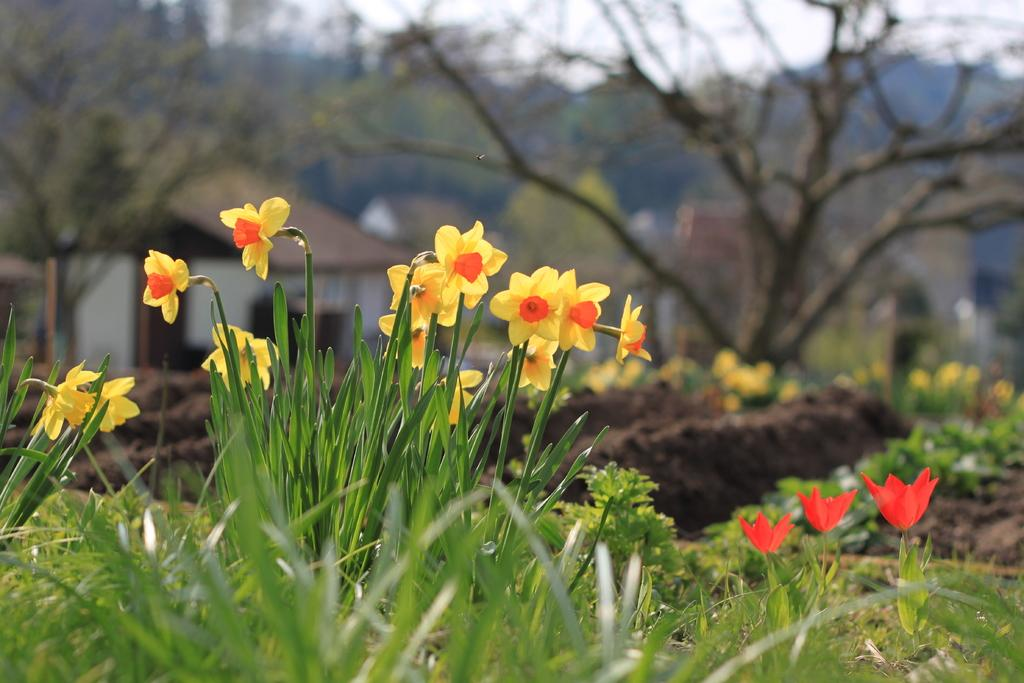What type of living organisms can be seen in the image? Plants can be seen in the image. What specific feature can be observed on the plants? The plants have flowers on them. How many bricks can be seen supporting the plants in the image? There are no bricks present in the image; the plants are not supported by any bricks. Can you describe the sponge used for watering the plants in the image? There is no sponge visible in the image, and no mention of watering the plants. 